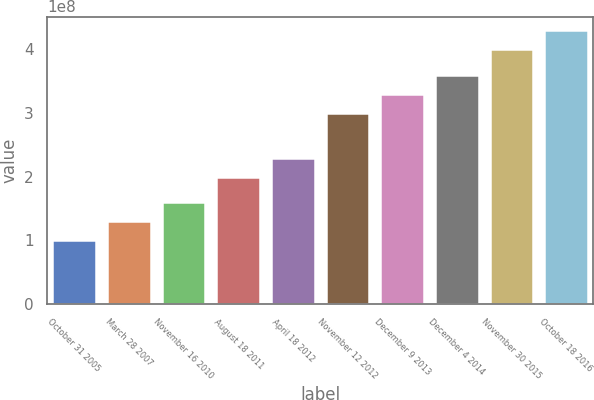Convert chart. <chart><loc_0><loc_0><loc_500><loc_500><bar_chart><fcel>October 31 2005<fcel>March 28 2007<fcel>November 16 2010<fcel>August 18 2011<fcel>April 18 2012<fcel>November 12 2012<fcel>December 9 2013<fcel>December 4 2014<fcel>November 30 2015<fcel>October 18 2016<nl><fcel>1e+08<fcel>1.3e+08<fcel>1.6e+08<fcel>2e+08<fcel>2.3e+08<fcel>3e+08<fcel>3.3e+08<fcel>3.6e+08<fcel>4e+08<fcel>4.3e+08<nl></chart> 